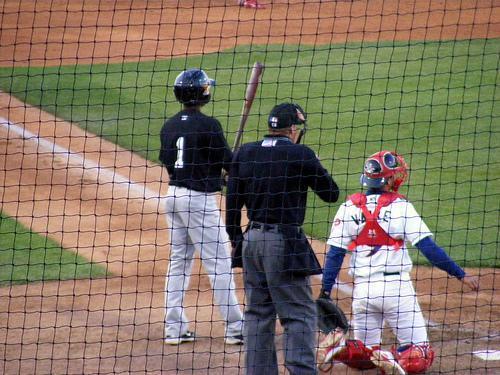How many people are shown?
Give a very brief answer. 3. 